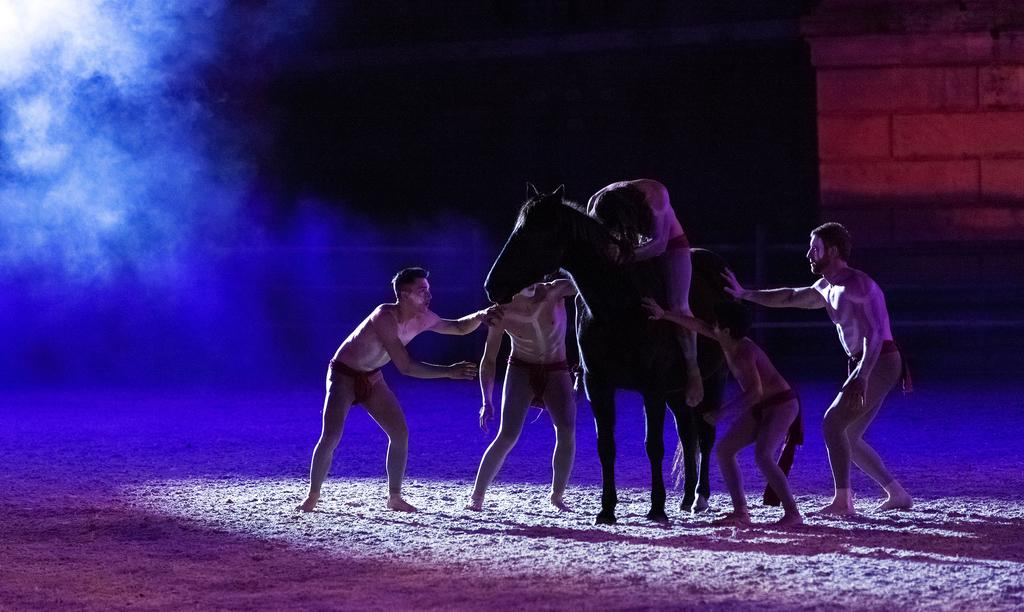What are the people in the image doing? The people in the image are standing on the grass. What animal is present in the image? There is a horse in the image. Is anyone interacting with the horse? Yes, a person is sitting on the horse. What can be seen in the background of the image? There is a wall in the background of the image. How would you describe the lighting in the image? The background is dark in the image. Can you tell me how many cars are driving in the image? There are no cars present in the image. Is the person sitting on the horse wearing a cast? There is no information about the person's attire or any cast in the image. 